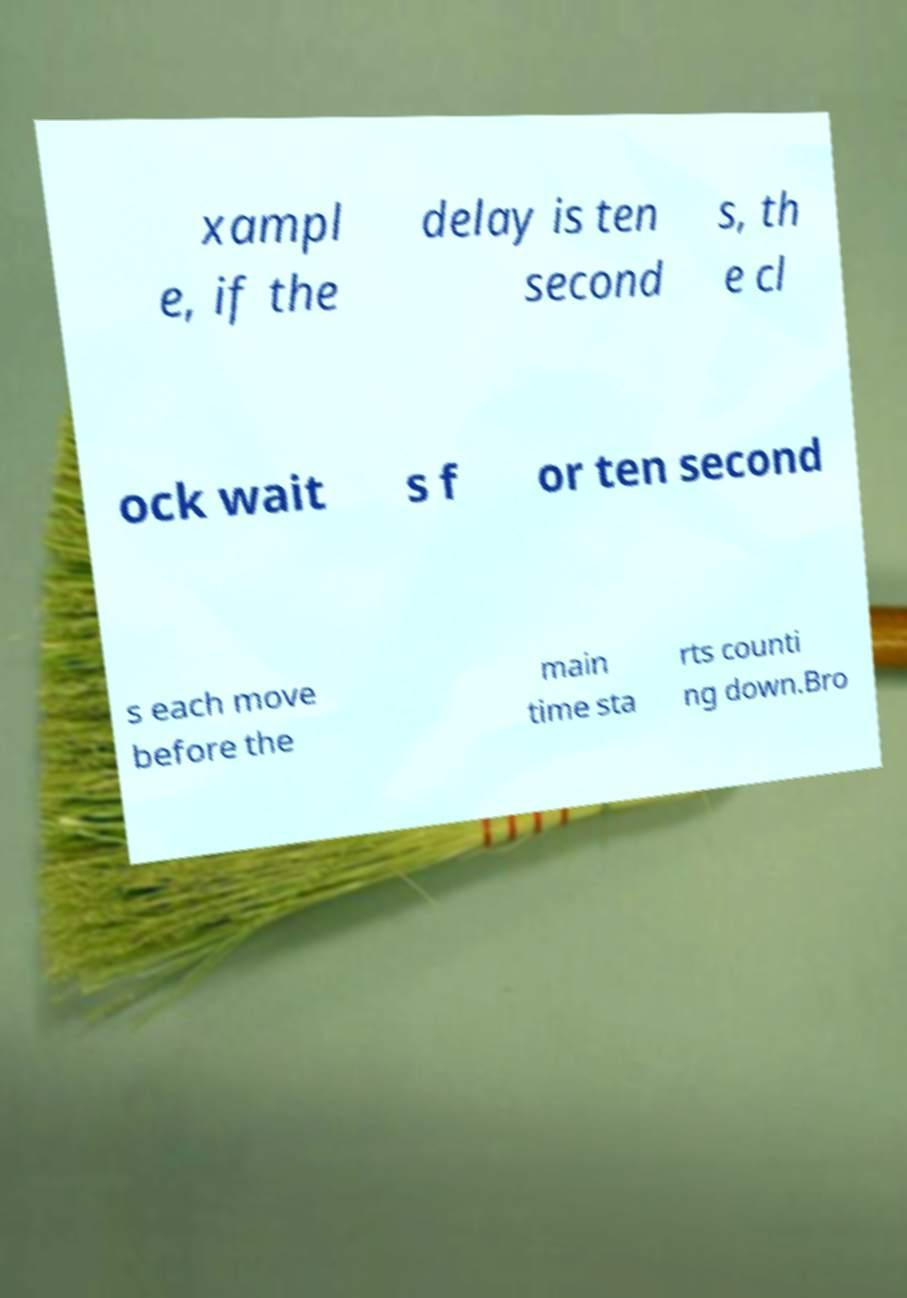For documentation purposes, I need the text within this image transcribed. Could you provide that? xampl e, if the delay is ten second s, th e cl ock wait s f or ten second s each move before the main time sta rts counti ng down.Bro 